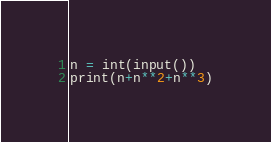Convert code to text. <code><loc_0><loc_0><loc_500><loc_500><_Python_>n = int(input())
print(n+n**2+n**3)</code> 